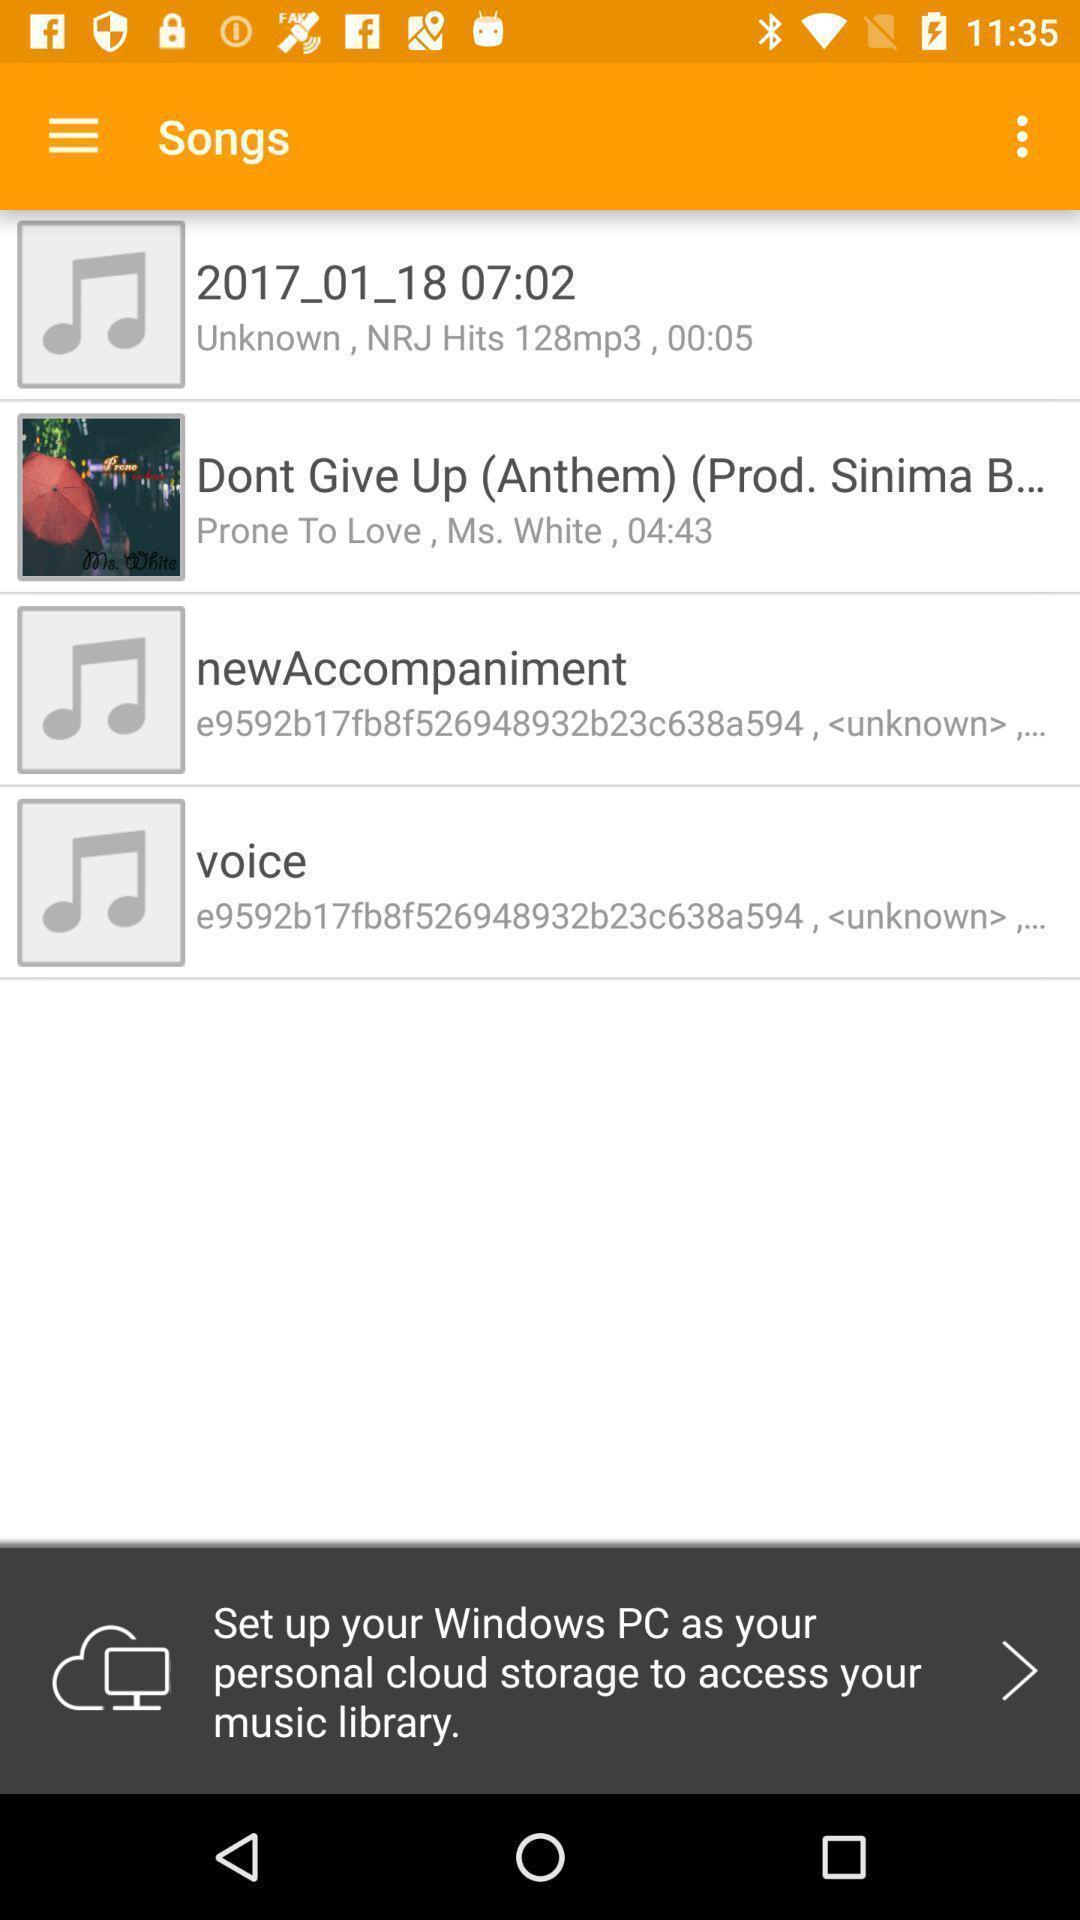Give me a narrative description of this picture. Screen displaying multiple audio files with time duration. 